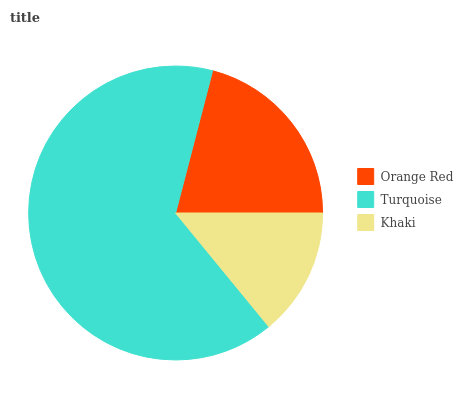Is Khaki the minimum?
Answer yes or no. Yes. Is Turquoise the maximum?
Answer yes or no. Yes. Is Turquoise the minimum?
Answer yes or no. No. Is Khaki the maximum?
Answer yes or no. No. Is Turquoise greater than Khaki?
Answer yes or no. Yes. Is Khaki less than Turquoise?
Answer yes or no. Yes. Is Khaki greater than Turquoise?
Answer yes or no. No. Is Turquoise less than Khaki?
Answer yes or no. No. Is Orange Red the high median?
Answer yes or no. Yes. Is Orange Red the low median?
Answer yes or no. Yes. Is Khaki the high median?
Answer yes or no. No. Is Turquoise the low median?
Answer yes or no. No. 